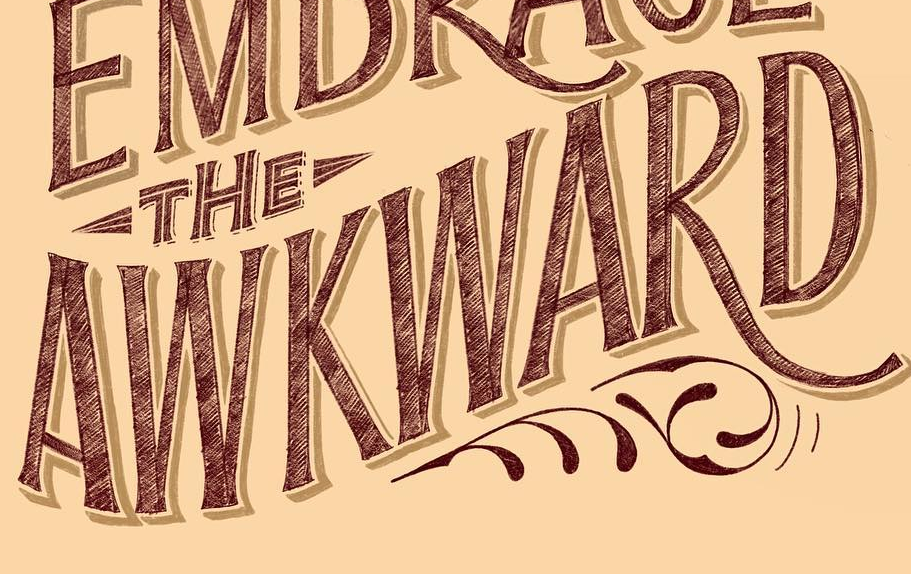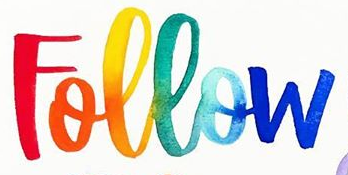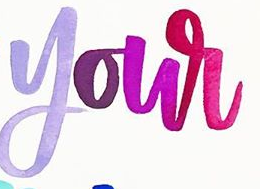What text appears in these images from left to right, separated by a semicolon? AWKWARD; Follow; your 